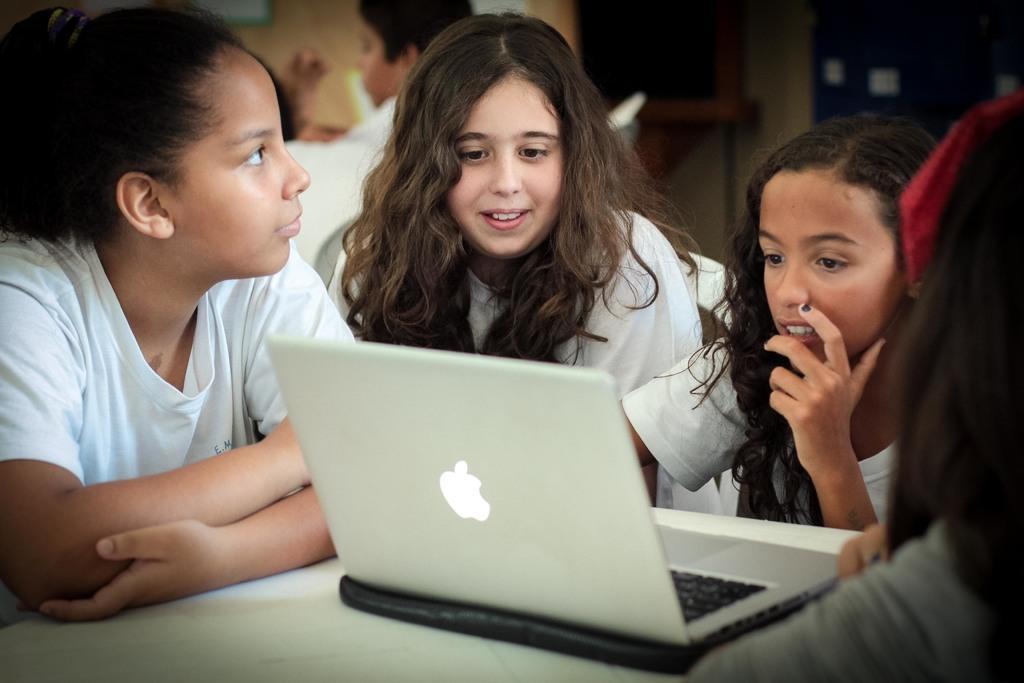Describe this image in one or two sentences. In this image there are a few kids watching something on the laptop. 